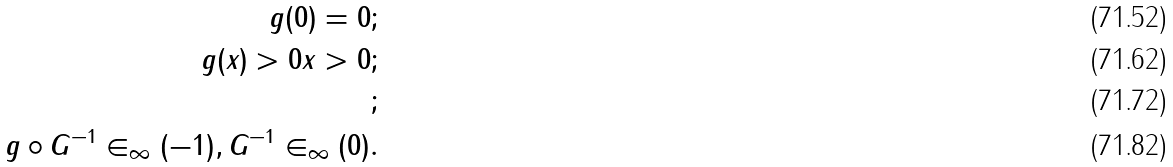Convert formula to latex. <formula><loc_0><loc_0><loc_500><loc_500>g ( 0 ) = 0 ; \\ g ( x ) > 0 x > 0 ; \\ ; \\ g \circ G ^ { - 1 } \in _ { \infty } ( - 1 ) , G ^ { - 1 } \in _ { \infty } ( 0 ) .</formula> 